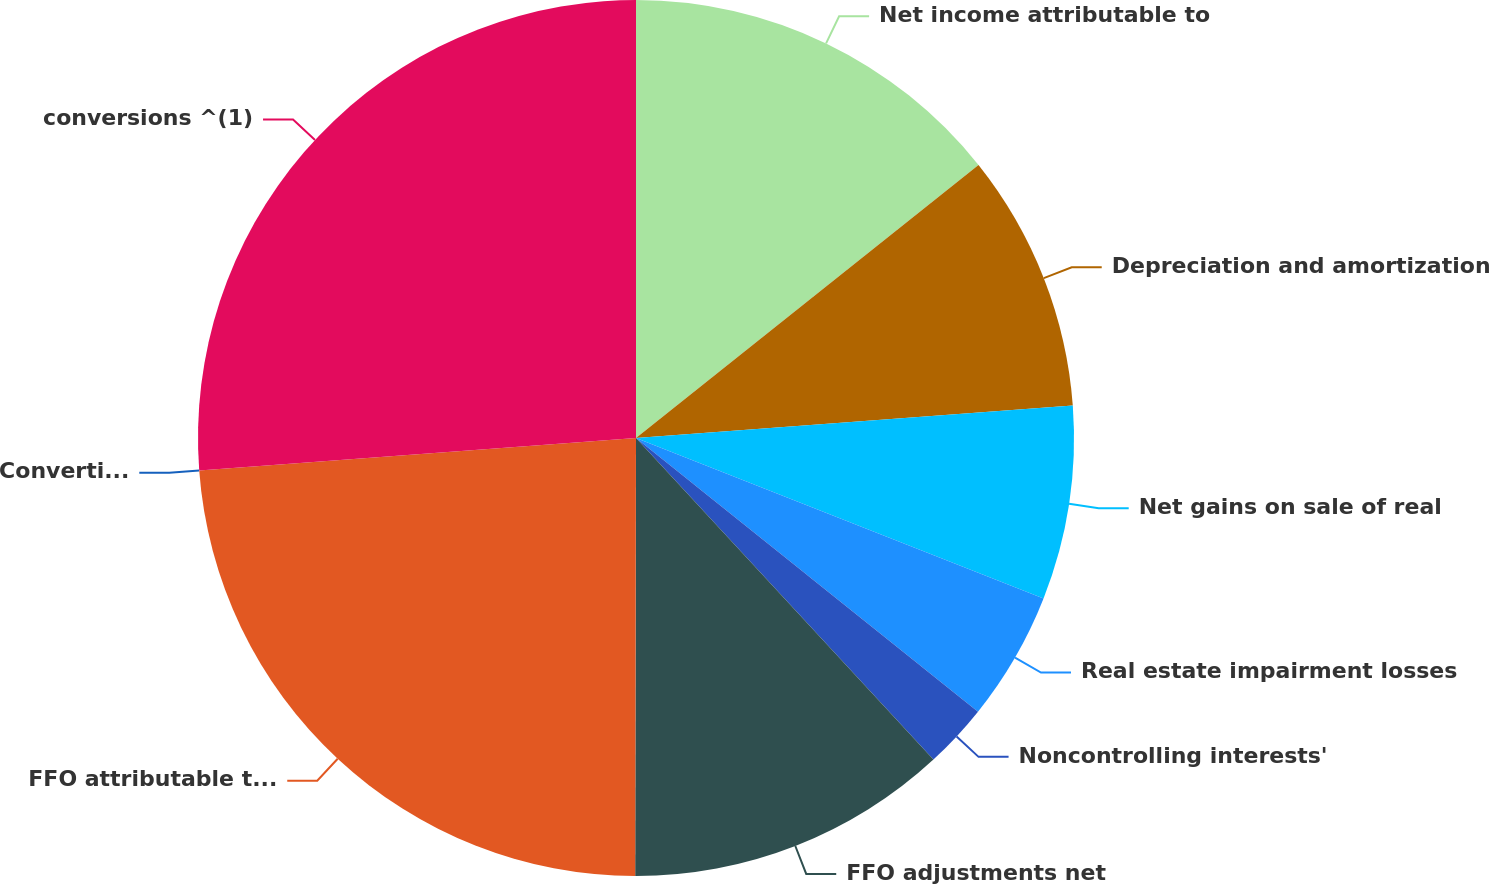Convert chart to OTSL. <chart><loc_0><loc_0><loc_500><loc_500><pie_chart><fcel>Net income attributable to<fcel>Depreciation and amortization<fcel>Net gains on sale of real<fcel>Real estate impairment losses<fcel>Noncontrolling interests'<fcel>FFO adjustments net<fcel>FFO attributable to common<fcel>Convertible preferred share<fcel>conversions ^(1)<nl><fcel>14.29%<fcel>9.53%<fcel>7.15%<fcel>4.77%<fcel>2.38%<fcel>11.91%<fcel>23.79%<fcel>0.0%<fcel>26.18%<nl></chart> 